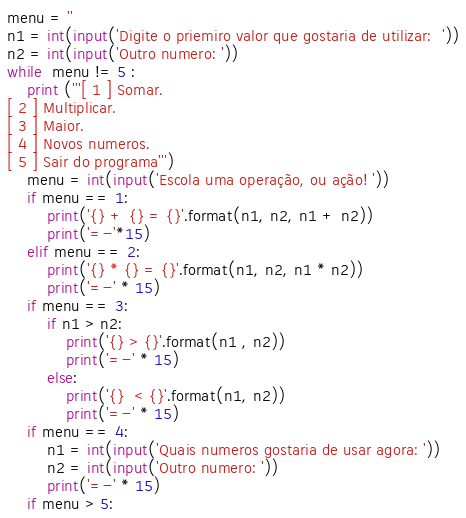<code> <loc_0><loc_0><loc_500><loc_500><_Python_>
menu = ''
n1 = int(input('Digite o priemiro valor que gostaria de utilizar:  '))
n2 = int(input('Outro numero: '))
while  menu != 5 :
    print ('''[ 1 ] Somar.
[ 2 ] Multiplicar.
[ 3 ] Maior.
[ 4 ] Novos numeros.
[ 5 ] Sair do programa''')
    menu = int(input('Escola uma operação, ou ação! '))
    if menu == 1:
        print('{} + {} = {}'.format(n1, n2, n1 + n2))
        print('=-'*15)
    elif menu == 2:
        print('{} * {} = {}'.format(n1, n2, n1 * n2))
        print('=-' * 15)
    if menu == 3:
        if n1 > n2:
            print('{} > {}'.format(n1 , n2))
            print('=-' * 15)
        else:
            print('{}  < {}'.format(n1, n2))
            print('=-' * 15)
    if menu == 4:
        n1 = int(input('Quais numeros gostaria de usar agora: '))
        n2 = int(input('Outro numero: '))
        print('=-' * 15)
    if menu > 5:</code> 